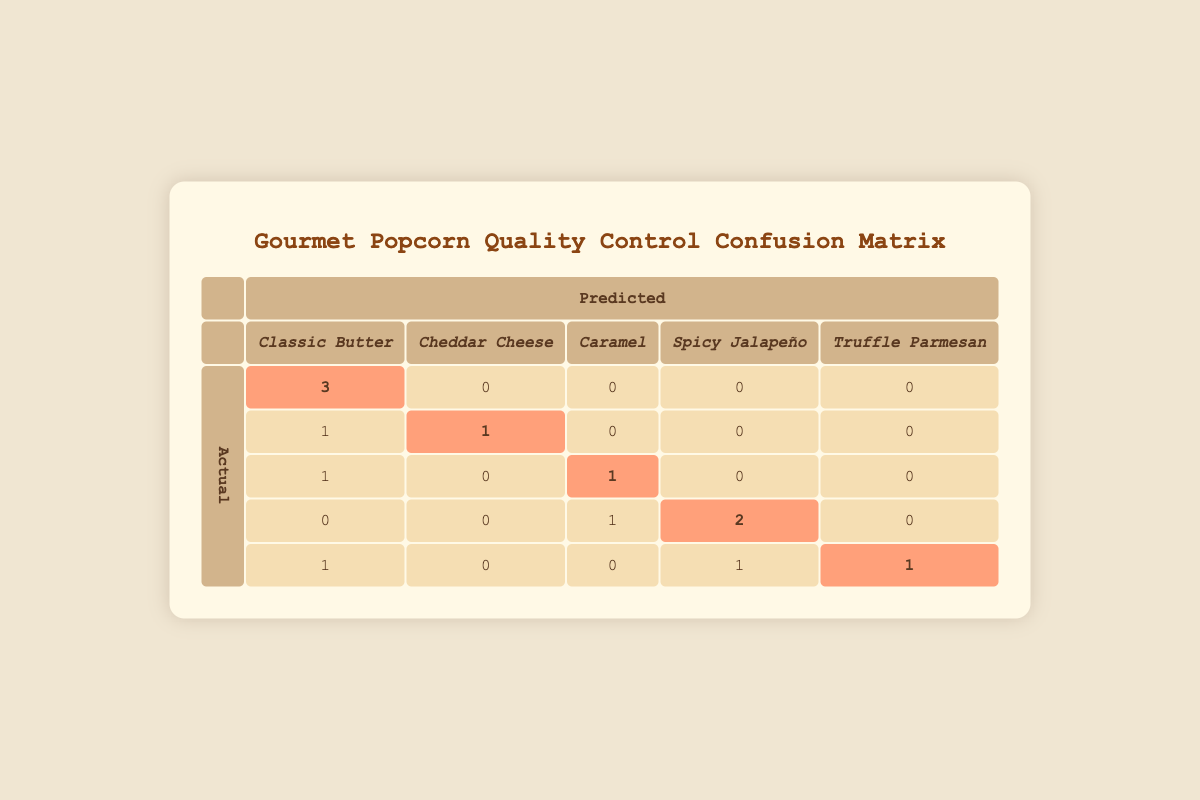What is the True Positive count for Classic Butter? The True Positive count for Classic Butter is given directly in the table under the evaluation section for that flavor, listed as 3.
Answer: 3 How many False Positives were predicted for Cheddar Cheese? The false positives for Cheddar Cheese are indicated in the table as 0. This means there were no instances where Cheddar Cheese was incorrectly predicted.
Answer: 0 What is the total number of True Positives across all popcorn flavors? To find the total True Positives, we sum the True Positive counts of each flavor: 3 (Classic Butter) + 1 (Cheddar Cheese) + 1 (Caramel) + 2 (Spicy Jalapeño) + 1 (Truffle Parmesan) = 8.
Answer: 8 For the Spicy Jalapeño variant, what is the count of True Negatives? From the table, we see that the True Negative count for Spicy Jalapeño is 4, indicating the model accurately identified 4 instances as not being Spicy Jalapeño.
Answer: 4 Is it true that Caramel had more True Positives than False Negatives? The True Positive count for Caramel is 1 and the False Negative count is also 1, making the statement false since they are equal and not one greater than the other.
Answer: No What is the average True Positive count for all popcorn variants? To calculate the average True Positive count, we sum the True Positives: 3 (Classic Butter) + 1 (Cheddar Cheese) + 1 (Caramel) + 2 (Spicy Jalapeño) + 1 (Truffle Parmesan) = 8 total. We have 5 flavors, so the average is 8/5 = 1.6.
Answer: 1.6 How many total instances were mistakenly categorized as Classic Butter? There are 1 False Positive and 0 False Negatives for Classic Butter. Thus, the total instances mistakenly categorized as Classic Butter equals 1 (False Positive) + 0 (False Negative) = 1.
Answer: 1 What flavor had the highest true positive predictions? By reviewing the True Positive counts, Classic Butter has 3, which is the highest among the other flavors.
Answer: Classic Butter 